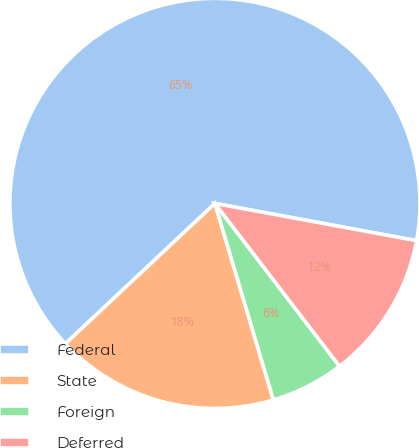Convert chart to OTSL. <chart><loc_0><loc_0><loc_500><loc_500><pie_chart><fcel>Federal<fcel>State<fcel>Foreign<fcel>Deferred<nl><fcel>64.9%<fcel>17.61%<fcel>5.79%<fcel>11.7%<nl></chart> 